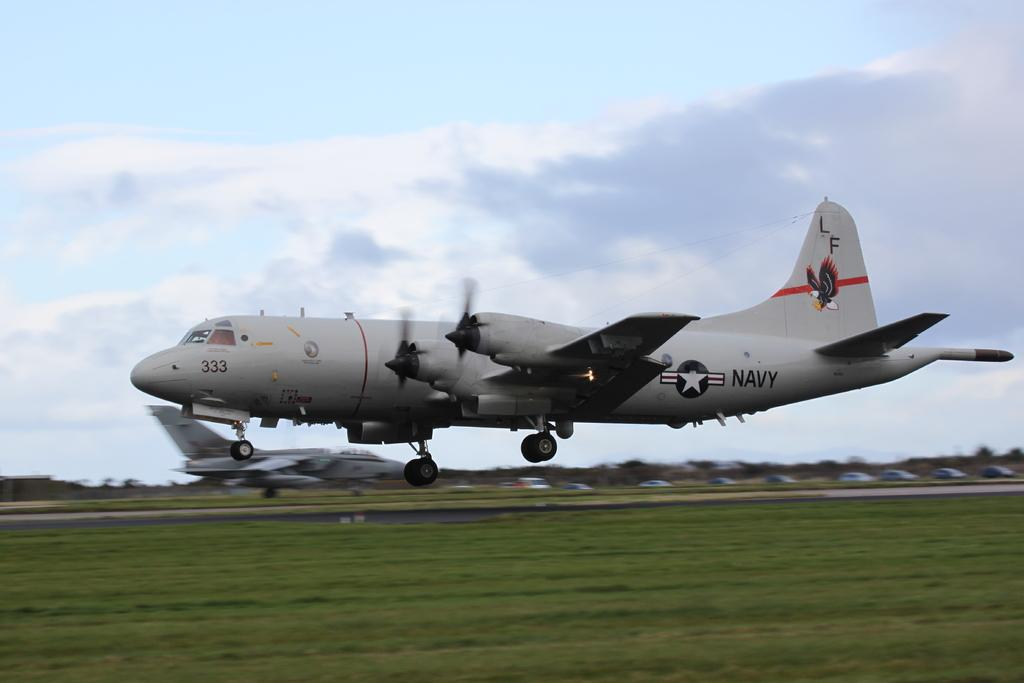<image>
Summarize the visual content of the image. An airplane with the letters LF written on the tail 